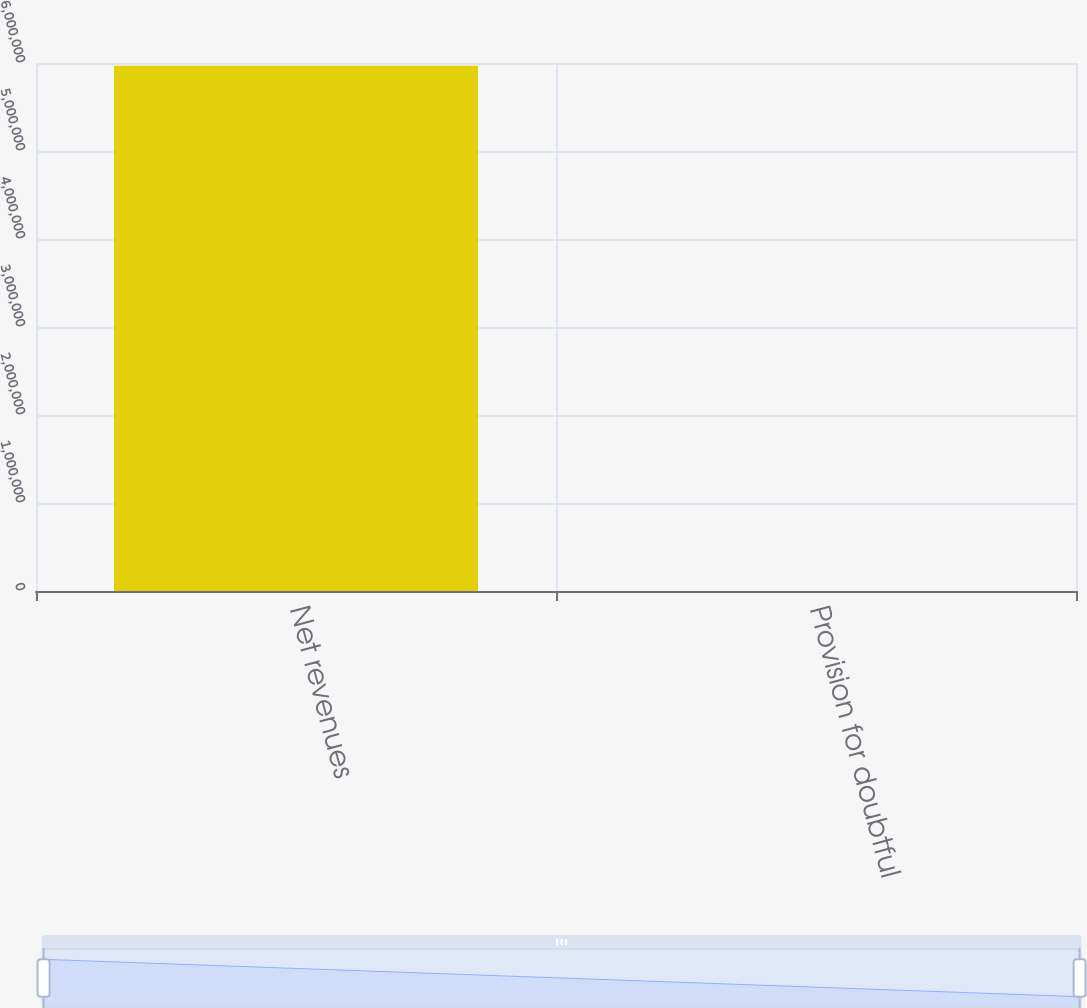<chart> <loc_0><loc_0><loc_500><loc_500><bar_chart><fcel>Net revenues<fcel>Provision for doubtful<nl><fcel>5.96974e+06<fcel>1.69<nl></chart> 